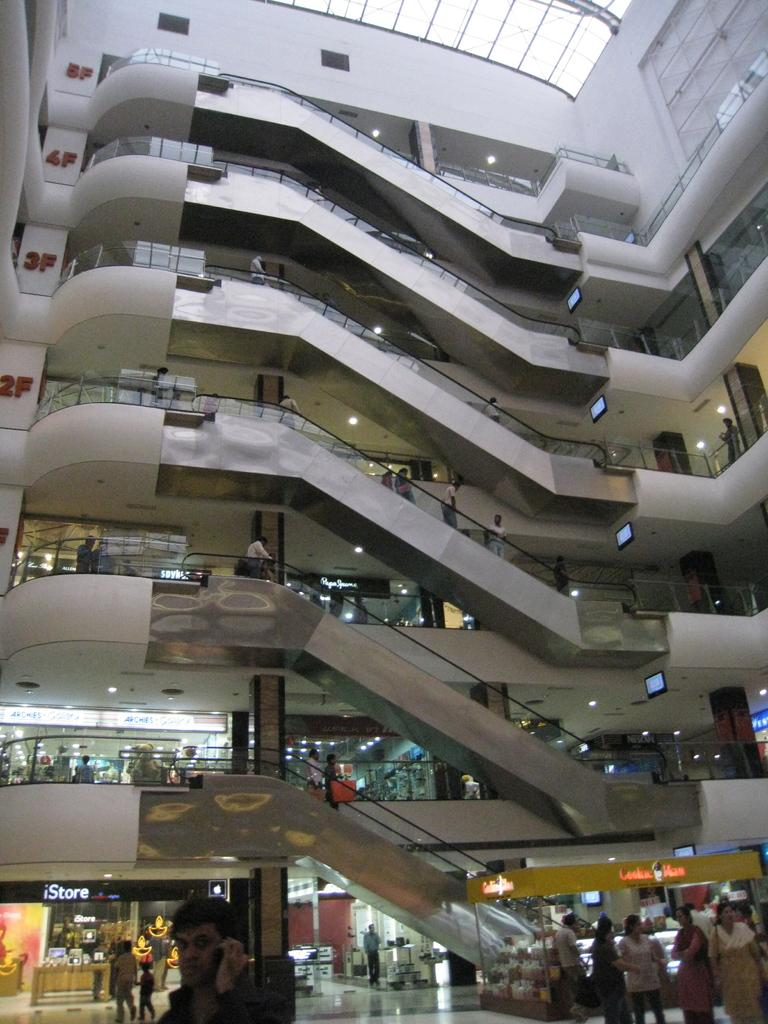What is the main structure in the middle of the image? There is a building in the middle of the image. What can be seen at the bottom of the image? There are many people and shops at the bottom of the image. What type of text is present in the image? Text is present in the image, likely on signs or posters. What kind of visuals are visible in the image? Posters and screens are visible in the image. What type of lighting is present in the image? Lights are present in the image, possibly illuminating the building or shops. What type of machinery is present in the image? Excavators are present in the image, suggesting construction or renovation work. What is the topmost feature of the image? There is a roof at the top of the image. How many babies are holding onto the balloon in the image? There are no babies or balloons present in the image. 